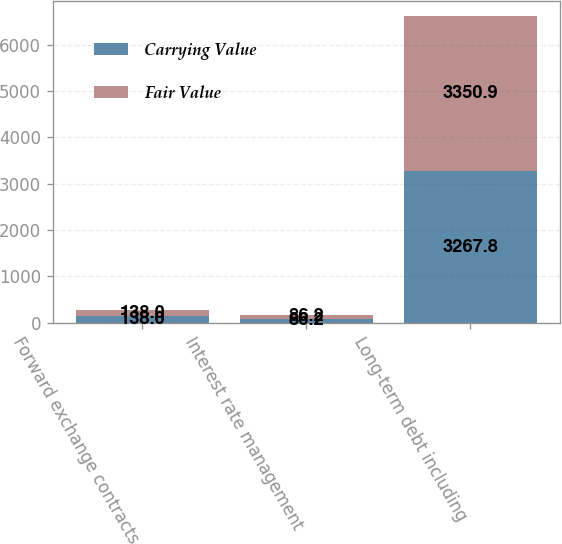<chart> <loc_0><loc_0><loc_500><loc_500><stacked_bar_chart><ecel><fcel>Forward exchange contracts<fcel>Interest rate management<fcel>Long-term debt including<nl><fcel>Carrying Value<fcel>138<fcel>86.2<fcel>3267.8<nl><fcel>Fair Value<fcel>138<fcel>86.2<fcel>3350.9<nl></chart> 